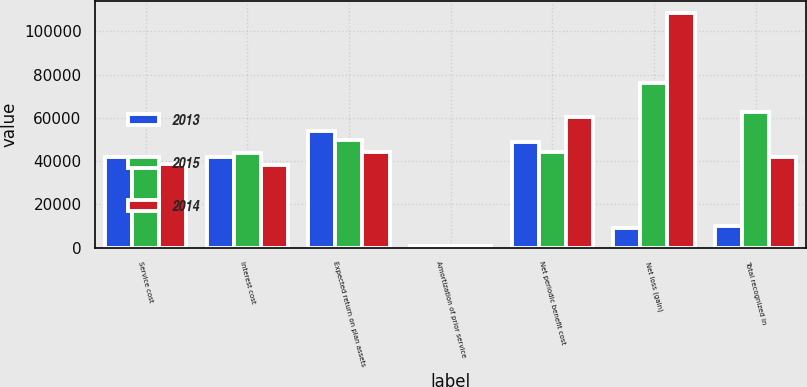<chart> <loc_0><loc_0><loc_500><loc_500><stacked_bar_chart><ecel><fcel>Service cost<fcel>Interest cost<fcel>Expected return on plan assets<fcel>Amortization of prior service<fcel>Net periodic benefit cost<fcel>Net loss (gain)<fcel>Total recognized in<nl><fcel>2013<fcel>41989<fcel>41766<fcel>53868<fcel>933<fcel>48956<fcel>9099<fcel>10215<nl><fcel>2015<fcel>36609<fcel>43613<fcel>49552<fcel>847<fcel>44298<fcel>75909<fcel>62724<nl><fcel>2014<fcel>38580<fcel>38243<fcel>44222<fcel>856<fcel>60273<fcel>108387<fcel>41766<nl></chart> 